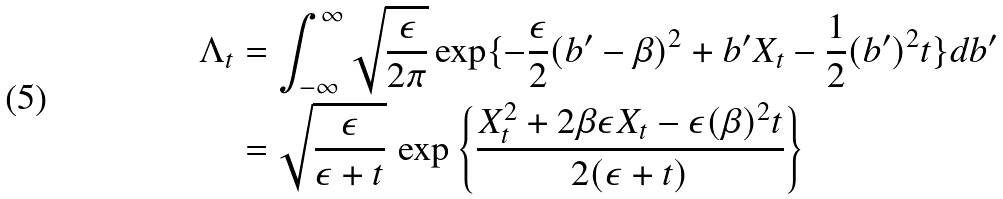Convert formula to latex. <formula><loc_0><loc_0><loc_500><loc_500>\Lambda _ { t } & = \int _ { - \infty } ^ { \infty } \sqrt { \frac { \epsilon } { 2 \pi } } \exp \{ - \frac { \epsilon } { 2 } ( b ^ { \prime } - \beta ) ^ { 2 } + b ^ { \prime } X _ { t } - \frac { 1 } { 2 } ( b ^ { \prime } ) ^ { 2 } t \} d b ^ { \prime } \\ & = \sqrt { \frac { \epsilon } { \epsilon + t } } \, \exp \left \{ \frac { X _ { t } ^ { 2 } + 2 \beta \epsilon X _ { t } - \epsilon ( \beta ) ^ { 2 } t } { 2 ( \epsilon + t ) } \right \}</formula> 